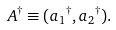Convert formula to latex. <formula><loc_0><loc_0><loc_500><loc_500>A ^ { \dagger } \equiv ( a { _ { 1 } } ^ { \dagger } , a { _ { 2 } } ^ { \dagger } ) .</formula> 